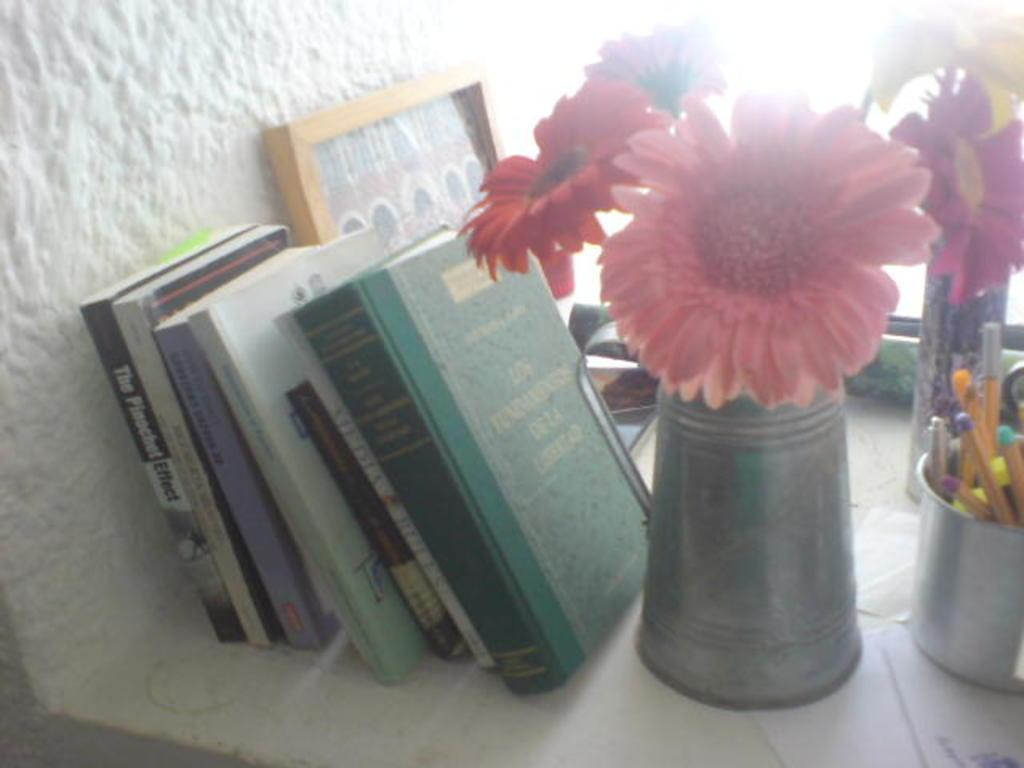What objects can be seen in the image related to reading or writing? There are books and a mug containing pens in the image. What type of container is present in the image for holding flowers? There is a flower vase in the image. What is the purpose of the frame in the image? The purpose of the frame is not specified, but it could be used for displaying photos or artwork. What is the mug used for besides holding pens? The mug is also used for holding a beverage, as it is designed for that purpose. What scent can be detected from the flower vase in the image? There is no information about the scent of the flowers in the image, as it is not mentioned in the provided facts. 